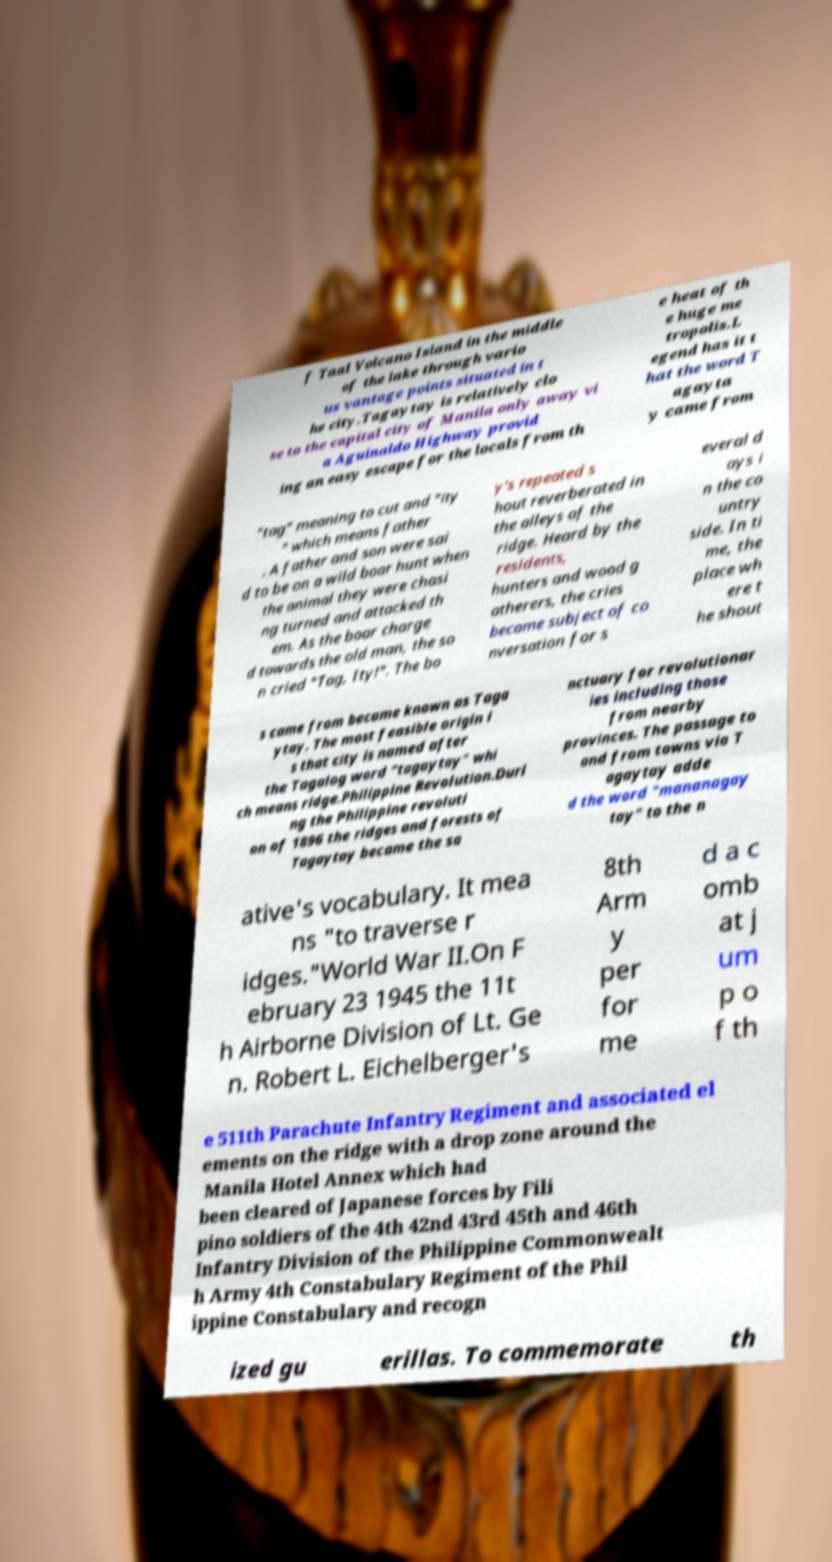What messages or text are displayed in this image? I need them in a readable, typed format. f Taal Volcano Island in the middle of the lake through vario us vantage points situated in t he city.Tagaytay is relatively clo se to the capital city of Manila only away vi a Aguinaldo Highway provid ing an easy escape for the locals from th e heat of th e huge me tropolis.L egend has it t hat the word T agayta y came from "tag" meaning to cut and "ity " which means father . A father and son were sai d to be on a wild boar hunt when the animal they were chasi ng turned and attacked th em. As the boar charge d towards the old man, the so n cried "Tag, Ity!". The bo y's repeated s hout reverberated in the alleys of the ridge. Heard by the residents, hunters and wood g atherers, the cries became subject of co nversation for s everal d ays i n the co untry side. In ti me, the place wh ere t he shout s came from became known as Taga ytay. The most feasible origin i s that city is named after the Tagalog word "tagaytay" whi ch means ridge.Philippine Revolution.Duri ng the Philippine revoluti on of 1896 the ridges and forests of Tagaytay became the sa nctuary for revolutionar ies including those from nearby provinces. The passage to and from towns via T agaytay adde d the word "mananagay tay" to the n ative's vocabulary. It mea ns "to traverse r idges."World War II.On F ebruary 23 1945 the 11t h Airborne Division of Lt. Ge n. Robert L. Eichelberger's 8th Arm y per for me d a c omb at j um p o f th e 511th Parachute Infantry Regiment and associated el ements on the ridge with a drop zone around the Manila Hotel Annex which had been cleared of Japanese forces by Fili pino soldiers of the 4th 42nd 43rd 45th and 46th Infantry Division of the Philippine Commonwealt h Army 4th Constabulary Regiment of the Phil ippine Constabulary and recogn ized gu erillas. To commemorate th 